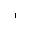<formula> <loc_0><loc_0><loc_500><loc_500>^ { 1 }</formula> 